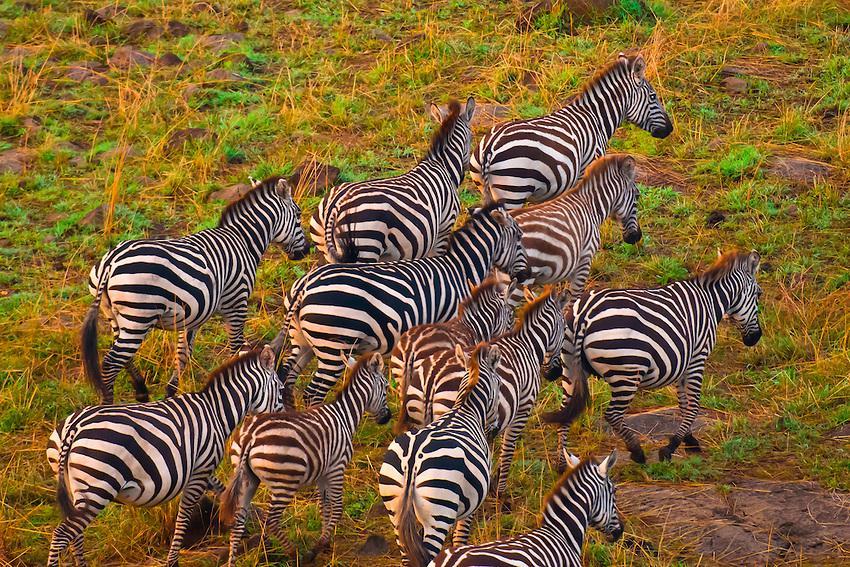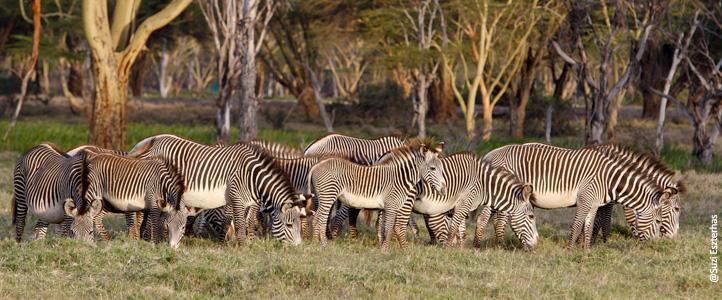The first image is the image on the left, the second image is the image on the right. Assess this claim about the two images: "One image shows zebras standing around grazing, and the other shows zebras that are all walking in one direction.". Correct or not? Answer yes or no. Yes. The first image is the image on the left, the second image is the image on the right. Evaluate the accuracy of this statement regarding the images: "In one of the images the zebras are all walking in the same direction.". Is it true? Answer yes or no. Yes. 